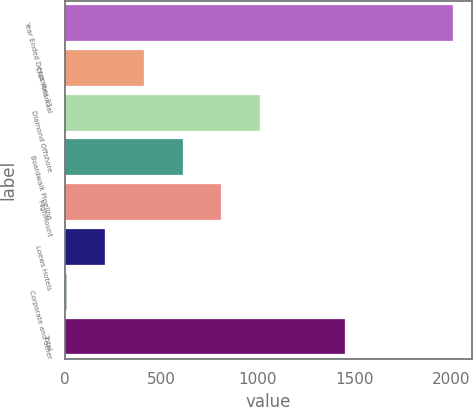Convert chart. <chart><loc_0><loc_0><loc_500><loc_500><bar_chart><fcel>Year Ended December 31<fcel>CNA Financial<fcel>Diamond Offshore<fcel>Boardwalk Pipeline<fcel>HighMount<fcel>Loews Hotels<fcel>Corporate and other<fcel>Total<nl><fcel>2012<fcel>410.4<fcel>1011<fcel>610.6<fcel>810.8<fcel>210.2<fcel>10<fcel>1452<nl></chart> 